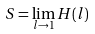Convert formula to latex. <formula><loc_0><loc_0><loc_500><loc_500>S = \lim _ { l \rightarrow 1 } H ( l )</formula> 